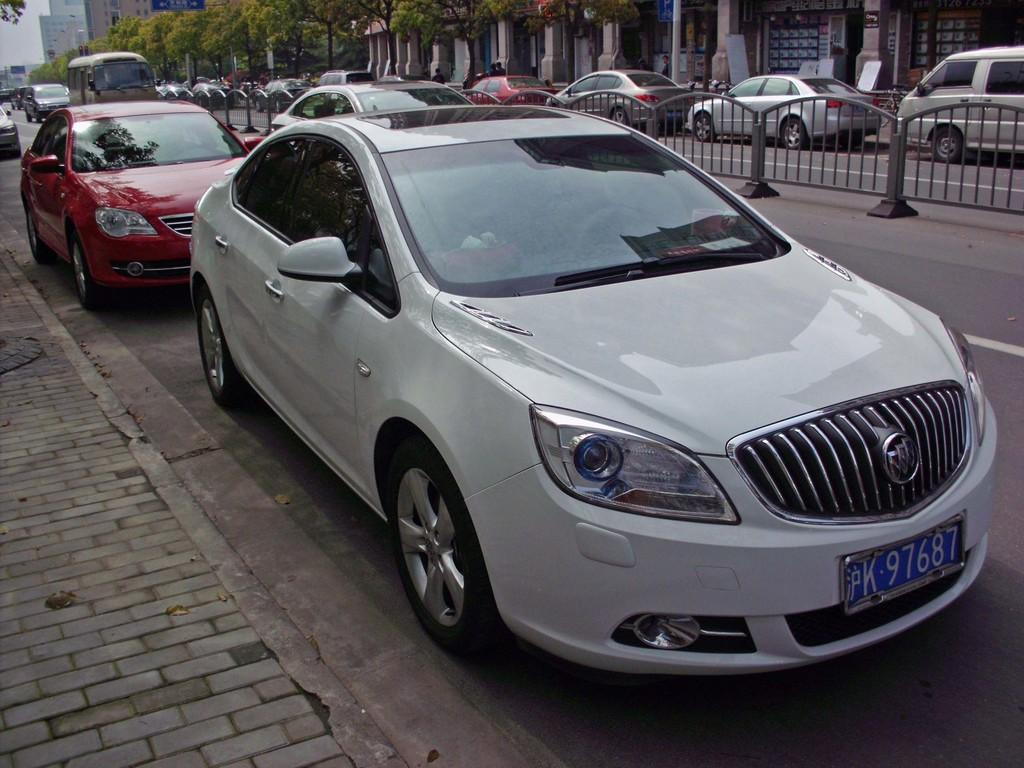What can be seen on the road in the image? There are vehicles on the road in the image. What is located near the road in the image? There is a fence in the image. What is visible in the background of the image? There are buildings, trees, and the sky visible in the background of the image. What type of chair is placed in the middle of the road in the image? There is no chair present in the image; it only features vehicles on the road. What surprise can be seen in the image? There is no surprise depicted in the image; it shows a typical scene with vehicles on the road, a fence, and background elements. 